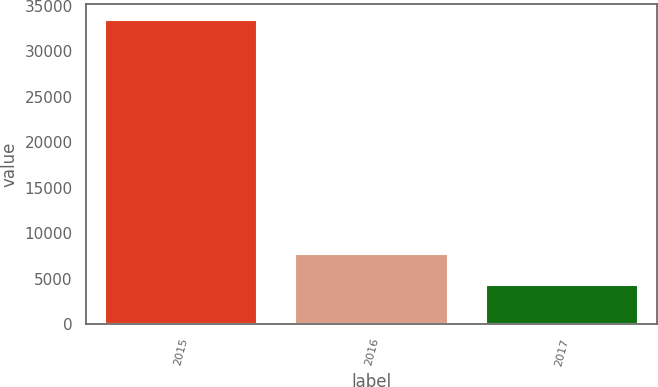<chart> <loc_0><loc_0><loc_500><loc_500><bar_chart><fcel>2015<fcel>2016<fcel>2017<nl><fcel>33509<fcel>7660<fcel>4317<nl></chart> 